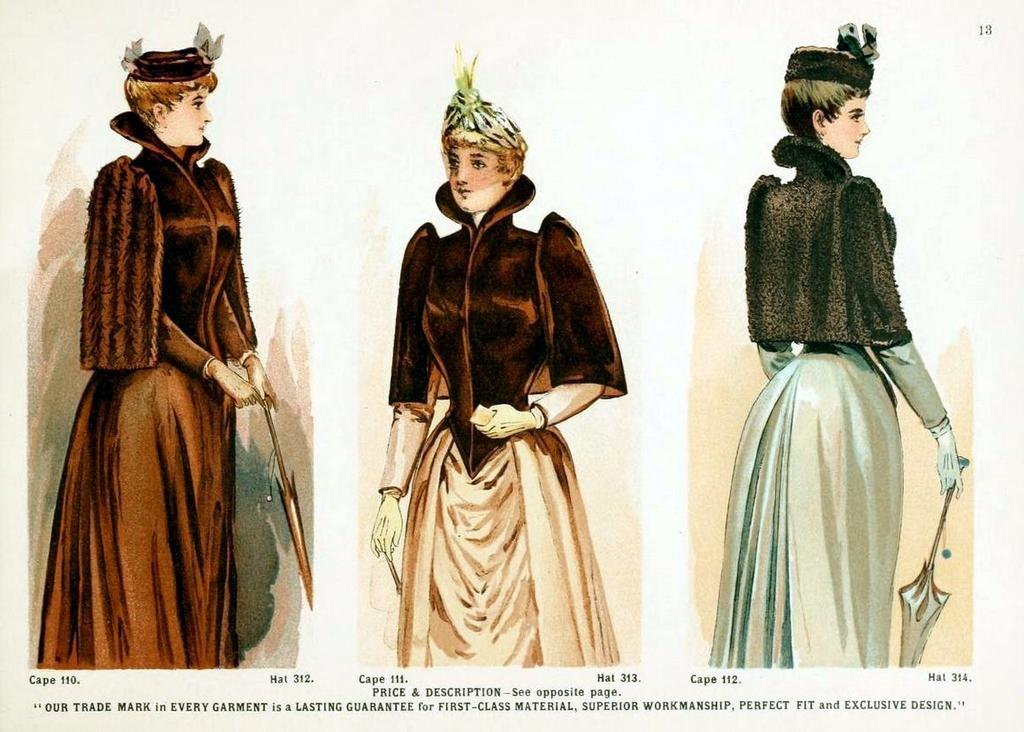What is the main subject of the three pictures in the image? The main subject of the three pictures is a person. Where are the pictures located in the image? The pictures are in the middle of the image. Is there any text present in the image? Yes, there is some text written in the bottom of the image. What type of shock can be seen affecting the person in the image? There is no shock or any indication of a shock in the image; it only features three drawing pictures of a person. Can you tell me how many baseballs are present in the image? There are no baseballs present in the image. 